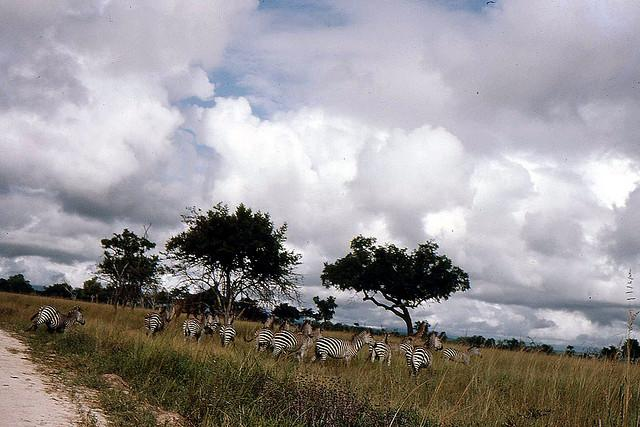The clouds in the sky depict that a is coming? storm 